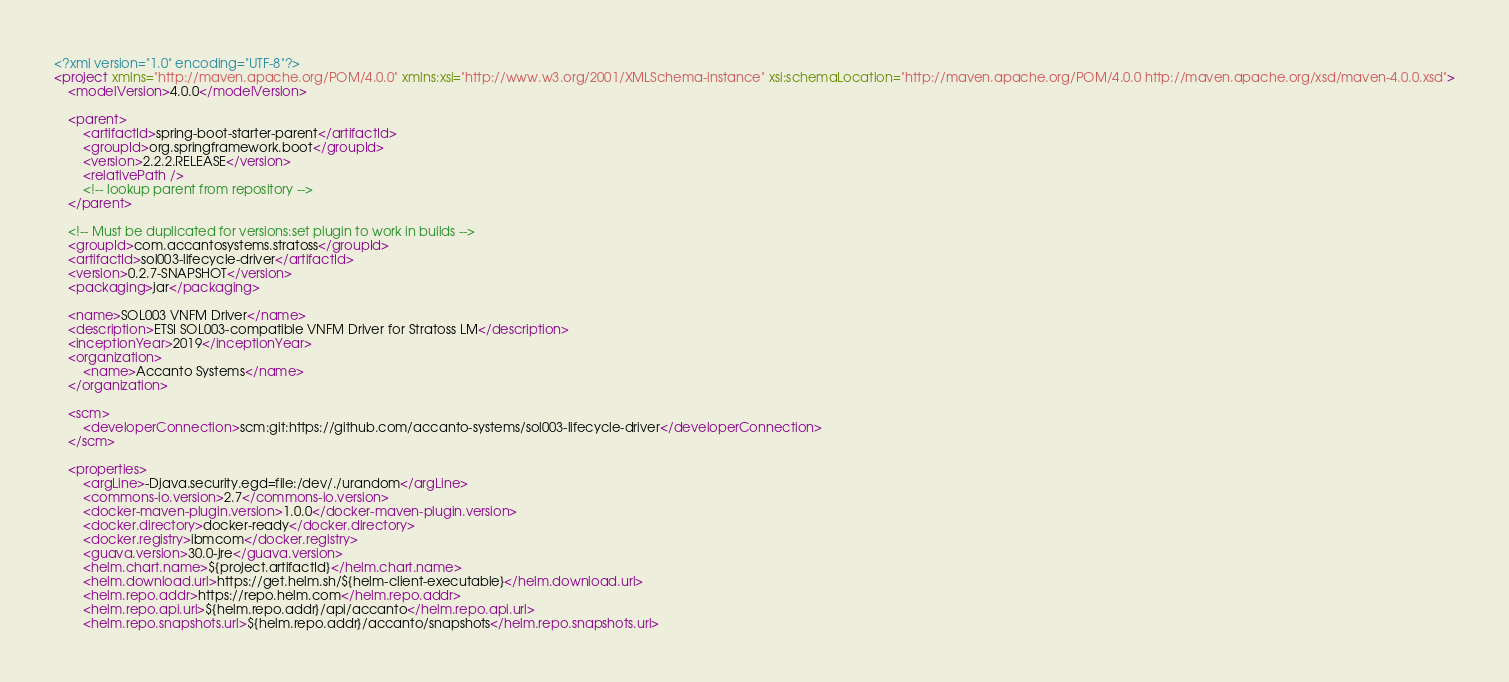<code> <loc_0><loc_0><loc_500><loc_500><_XML_><?xml version="1.0" encoding="UTF-8"?>
<project xmlns="http://maven.apache.org/POM/4.0.0" xmlns:xsi="http://www.w3.org/2001/XMLSchema-instance" xsi:schemaLocation="http://maven.apache.org/POM/4.0.0 http://maven.apache.org/xsd/maven-4.0.0.xsd">
    <modelVersion>4.0.0</modelVersion>

    <parent>
        <artifactId>spring-boot-starter-parent</artifactId>
        <groupId>org.springframework.boot</groupId>
        <version>2.2.2.RELEASE</version>
        <relativePath />
        <!-- lookup parent from repository -->
    </parent>

    <!-- Must be duplicated for versions:set plugin to work in builds -->
    <groupId>com.accantosystems.stratoss</groupId>
    <artifactId>sol003-lifecycle-driver</artifactId>
    <version>0.2.7-SNAPSHOT</version>
    <packaging>jar</packaging>

    <name>SOL003 VNFM Driver</name>
    <description>ETSI SOL003-compatible VNFM Driver for Stratoss LM</description>
    <inceptionYear>2019</inceptionYear>
    <organization>
        <name>Accanto Systems</name>
    </organization>

    <scm>
        <developerConnection>scm:git:https://github.com/accanto-systems/sol003-lifecycle-driver</developerConnection>
    </scm>

    <properties>
        <argLine>-Djava.security.egd=file:/dev/./urandom</argLine>
        <commons-io.version>2.7</commons-io.version>
        <docker-maven-plugin.version>1.0.0</docker-maven-plugin.version>
        <docker.directory>docker-ready</docker.directory>
        <docker.registry>ibmcom</docker.registry>
        <guava.version>30.0-jre</guava.version>
        <helm.chart.name>${project.artifactId}</helm.chart.name>
        <helm.download.url>https://get.helm.sh/${helm-client-executable}</helm.download.url>
        <helm.repo.addr>https://repo.helm.com</helm.repo.addr>
        <helm.repo.api.url>${helm.repo.addr}/api/accanto</helm.repo.api.url>
        <helm.repo.snapshots.url>${helm.repo.addr}/accanto/snapshots</helm.repo.snapshots.url></code> 